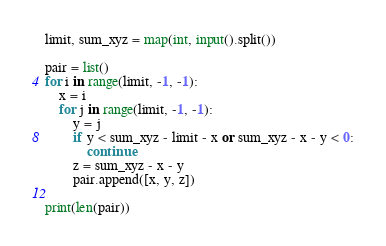Convert code to text. <code><loc_0><loc_0><loc_500><loc_500><_Python_>limit, sum_xyz = map(int, input().split())

pair = list()
for i in range(limit, -1, -1):
    x = i
    for j in range(limit, -1, -1):
        y = j
        if y < sum_xyz - limit - x or sum_xyz - x - y < 0:
            continue
        z = sum_xyz - x - y
        pair.append([x, y, z])

print(len(pair))</code> 